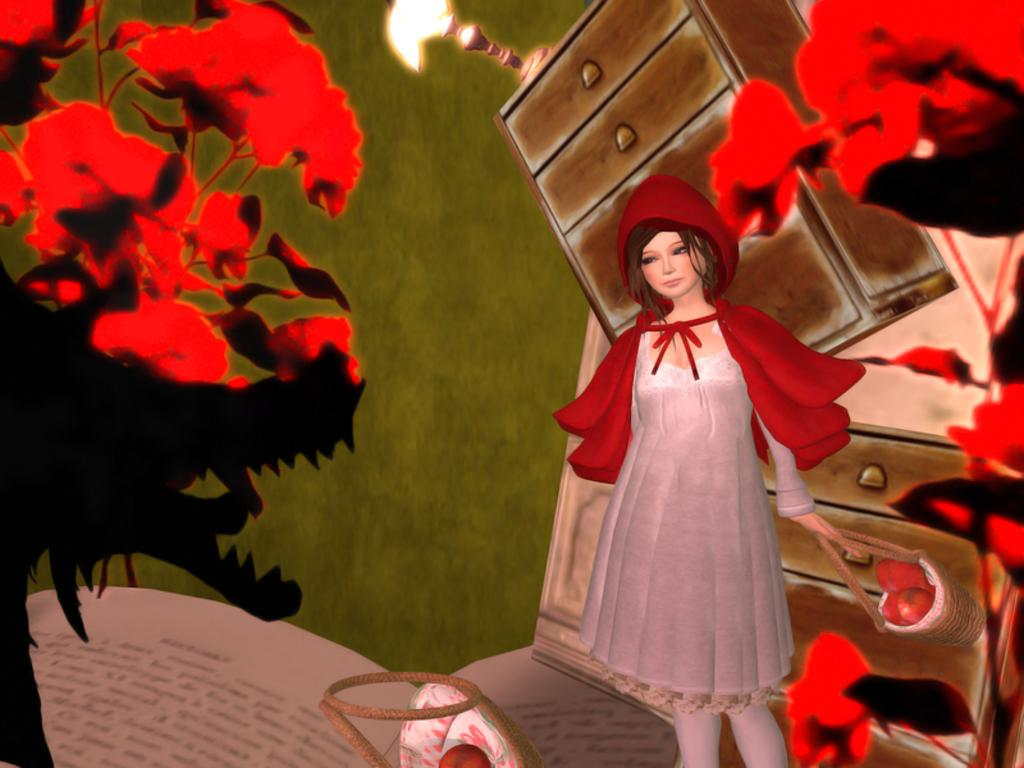What is the main subject of the image? There is a painting in the image. What is depicted in the painting? The painting depicts red color flowers and a plant. What else can be seen in the painting? A woman and books are present in the painting. What is the setting of the painting? The painting is on a wall, which is visible in the image. What is the source of light in the image? There is a light source in the image. What other objects are present in the room? There are cupboards in the image. What type of pocket can be seen in the painting? There is no pocket present in the painting; it depicts red color flowers, a plant, a woman, and books. What kind of pet is visible in the painting? There is no pet visible in the painting; it features red color flowers, a plant, a woman, and books. 